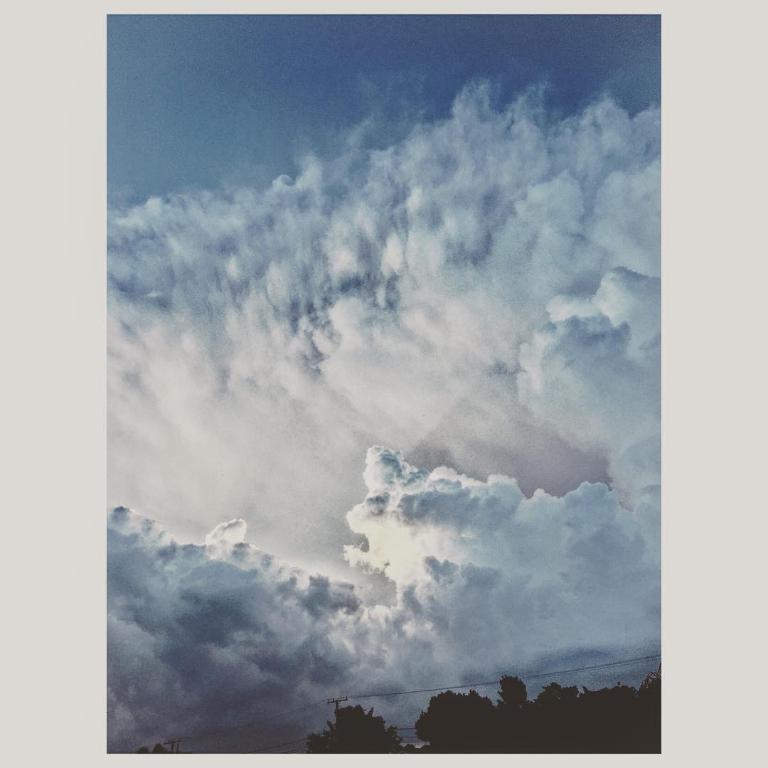Could you give a brief overview of what you see in this image? In this image we can see trees and transmission towers. And we can see the sky with clouds. 